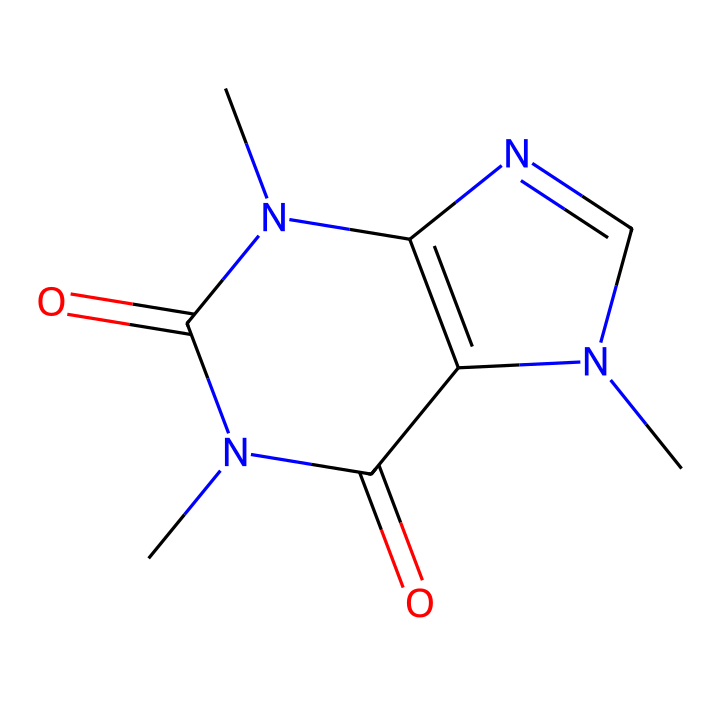What is the total number of carbon atoms in caffeine? By examining the SMILES representation, we can break it down and count the 'C' symbols. In the provided structure, there are a total of six carbon atoms present.
Answer: 6 How many nitrogen atoms are present in this chemical structure? In the SMILES notation, we count the 'N' symbols to determine the number of nitrogen atoms in caffeine. There are a total of four nitrogen atoms in the chemical structure.
Answer: 4 What functional groups are present in caffeine? Upon analyzing the structure, caffeine contains carbonyl (C=O) functional groups shown by the double bonds next to carbon atoms, and it also has nitrogen groups, indicating it includes amides (C=O and N).
Answer: carbonyl and amide Is caffeine an organic or inorganic compound? The presence of carbon atoms in the structure indicates that caffeine is indeed an organic compound, as organic compounds are primarily carbon-based.
Answer: organic What is the classification of caffeine in terms of solubility? Caffeine is classified as a non-electrolyte because it does not dissociate into ions in solution, illustrating that it remains intact when dissolved.
Answer: non-electrolyte How many rings are present in the structure of caffeine? By looking at the structural components in the SMILES representation, we can identify that caffeine consists of two interconnected ring structures.
Answer: 2 How many oxygen atoms are present in caffeine? We can find the number of oxygen atoms by counting the 'O' symbols in the SMILES notation. There are a total of two oxygen atoms in the caffeine structure.
Answer: 2 